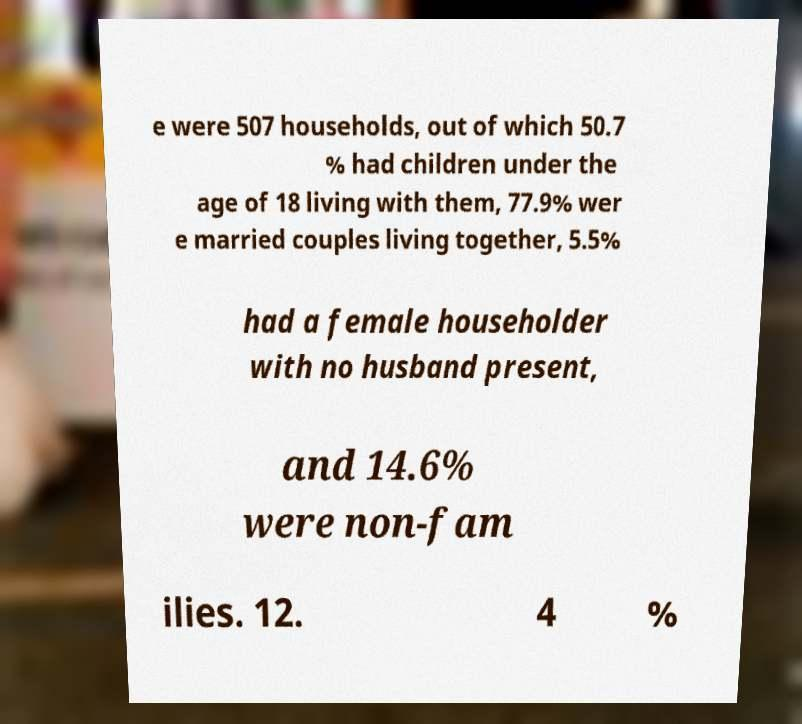Can you accurately transcribe the text from the provided image for me? e were 507 households, out of which 50.7 % had children under the age of 18 living with them, 77.9% wer e married couples living together, 5.5% had a female householder with no husband present, and 14.6% were non-fam ilies. 12. 4 % 